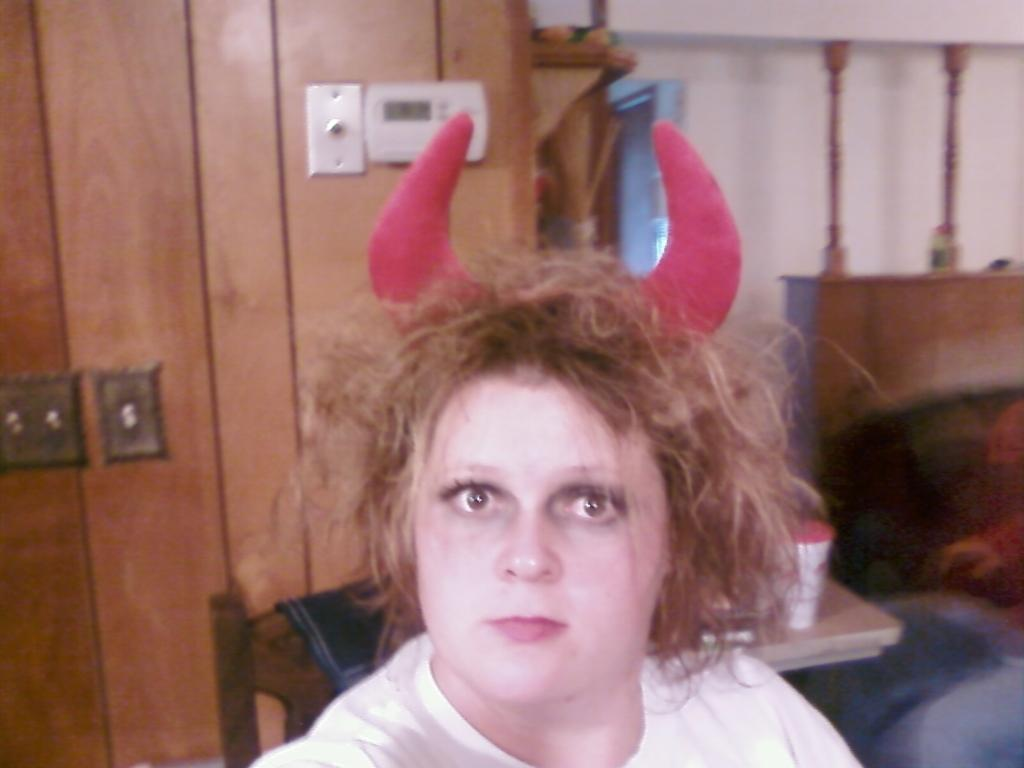What is the woman wearing in the image? The woman is wearing horns in the image. What can be seen behind the woman? There is a wall visible in the image. What is placed on the chair in the image? There is a napkin on a chair in the image. What is the position of the person in the image? There is a person sitting in the image. What is on the table in the image? There is a container on a table in the image. How much money is being given to the person in the image for their birthday? There is no mention of money or a birthday in the image, so we cannot determine if any money is being given or if it is someone's birthday. 